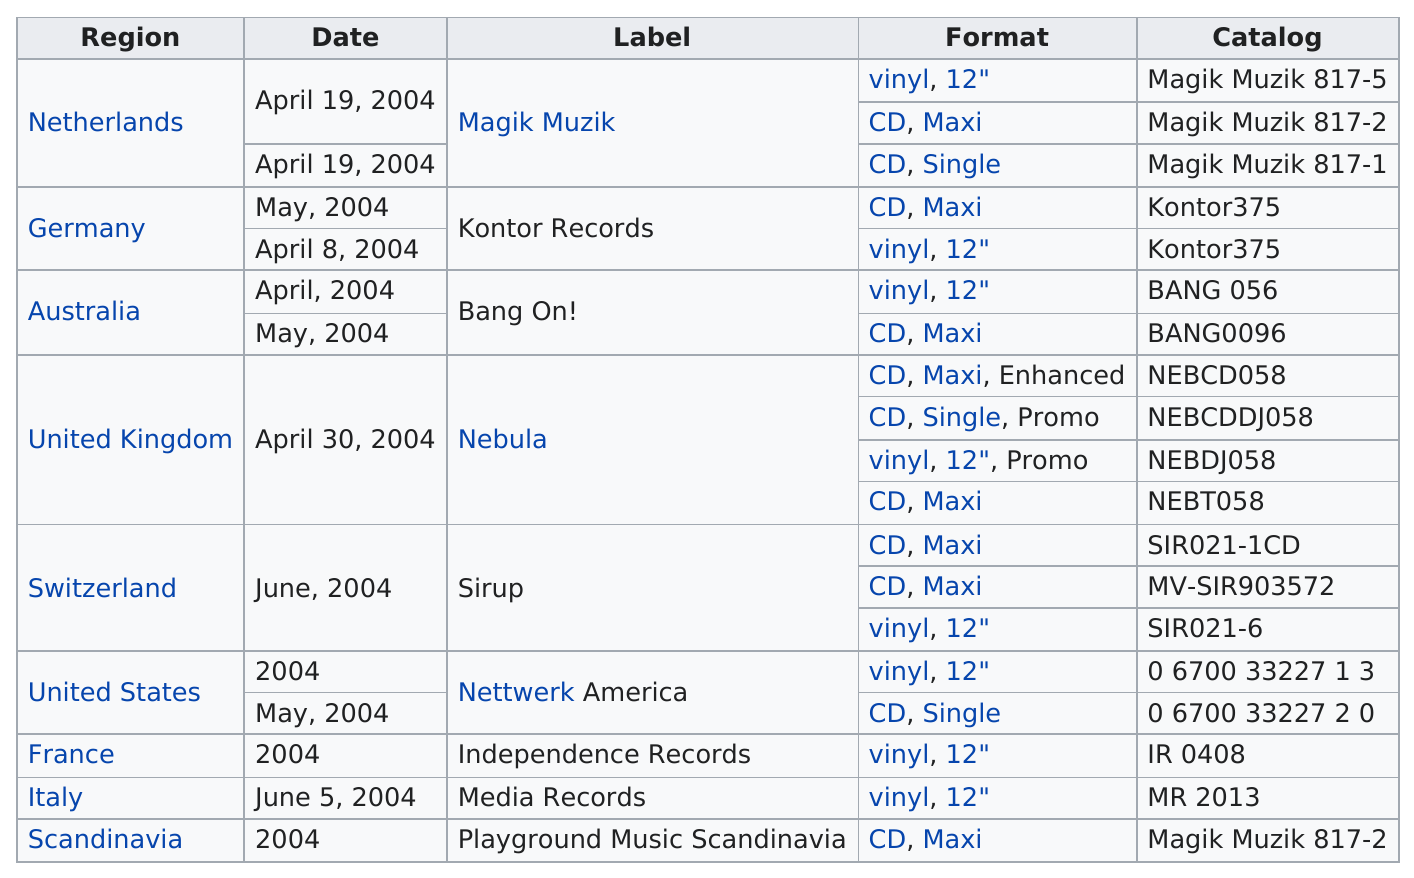Draw attention to some important aspects in this diagram. The label on the sirup container stated that it was produced in Switzerland. The Netherlands is listed at the top of the region. Italy was on the Media Records label. According to the information provided, 19 catalogs were released. The Sir021-1CD catalog included Switzerland. 